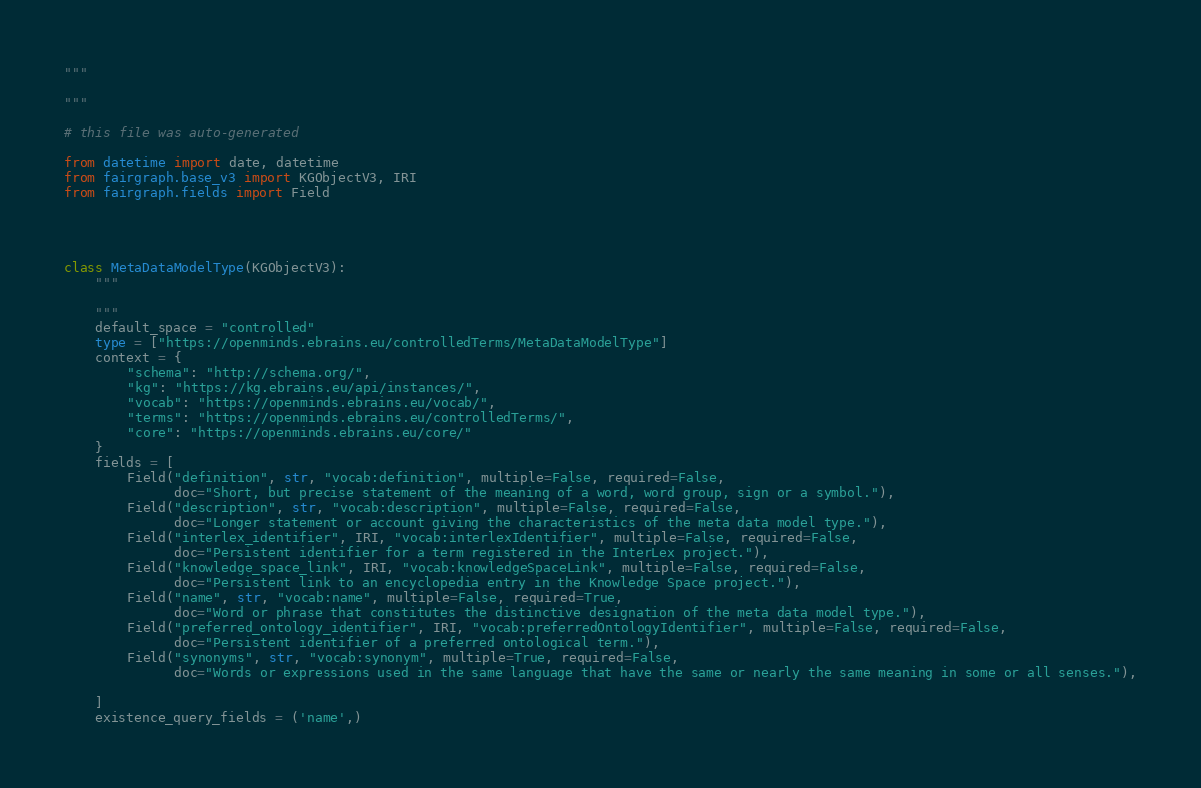Convert code to text. <code><loc_0><loc_0><loc_500><loc_500><_Python_>"""

"""

# this file was auto-generated

from datetime import date, datetime
from fairgraph.base_v3 import KGObjectV3, IRI
from fairgraph.fields import Field




class MetaDataModelType(KGObjectV3):
    """
    
    """
    default_space = "controlled"
    type = ["https://openminds.ebrains.eu/controlledTerms/MetaDataModelType"]
    context = {
        "schema": "http://schema.org/",
        "kg": "https://kg.ebrains.eu/api/instances/",
        "vocab": "https://openminds.ebrains.eu/vocab/",
        "terms": "https://openminds.ebrains.eu/controlledTerms/",
        "core": "https://openminds.ebrains.eu/core/"
    }
    fields = [
        Field("definition", str, "vocab:definition", multiple=False, required=False,
              doc="Short, but precise statement of the meaning of a word, word group, sign or a symbol."),
        Field("description", str, "vocab:description", multiple=False, required=False,
              doc="Longer statement or account giving the characteristics of the meta data model type."),
        Field("interlex_identifier", IRI, "vocab:interlexIdentifier", multiple=False, required=False,
              doc="Persistent identifier for a term registered in the InterLex project."),
        Field("knowledge_space_link", IRI, "vocab:knowledgeSpaceLink", multiple=False, required=False,
              doc="Persistent link to an encyclopedia entry in the Knowledge Space project."),
        Field("name", str, "vocab:name", multiple=False, required=True,
              doc="Word or phrase that constitutes the distinctive designation of the meta data model type."),
        Field("preferred_ontology_identifier", IRI, "vocab:preferredOntologyIdentifier", multiple=False, required=False,
              doc="Persistent identifier of a preferred ontological term."),
        Field("synonyms", str, "vocab:synonym", multiple=True, required=False,
              doc="Words or expressions used in the same language that have the same or nearly the same meaning in some or all senses."),
        
    ]
    existence_query_fields = ('name',)

</code> 